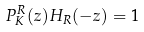Convert formula to latex. <formula><loc_0><loc_0><loc_500><loc_500>P _ { K } ^ { R } ( z ) H _ { R } ( - z ) = 1</formula> 